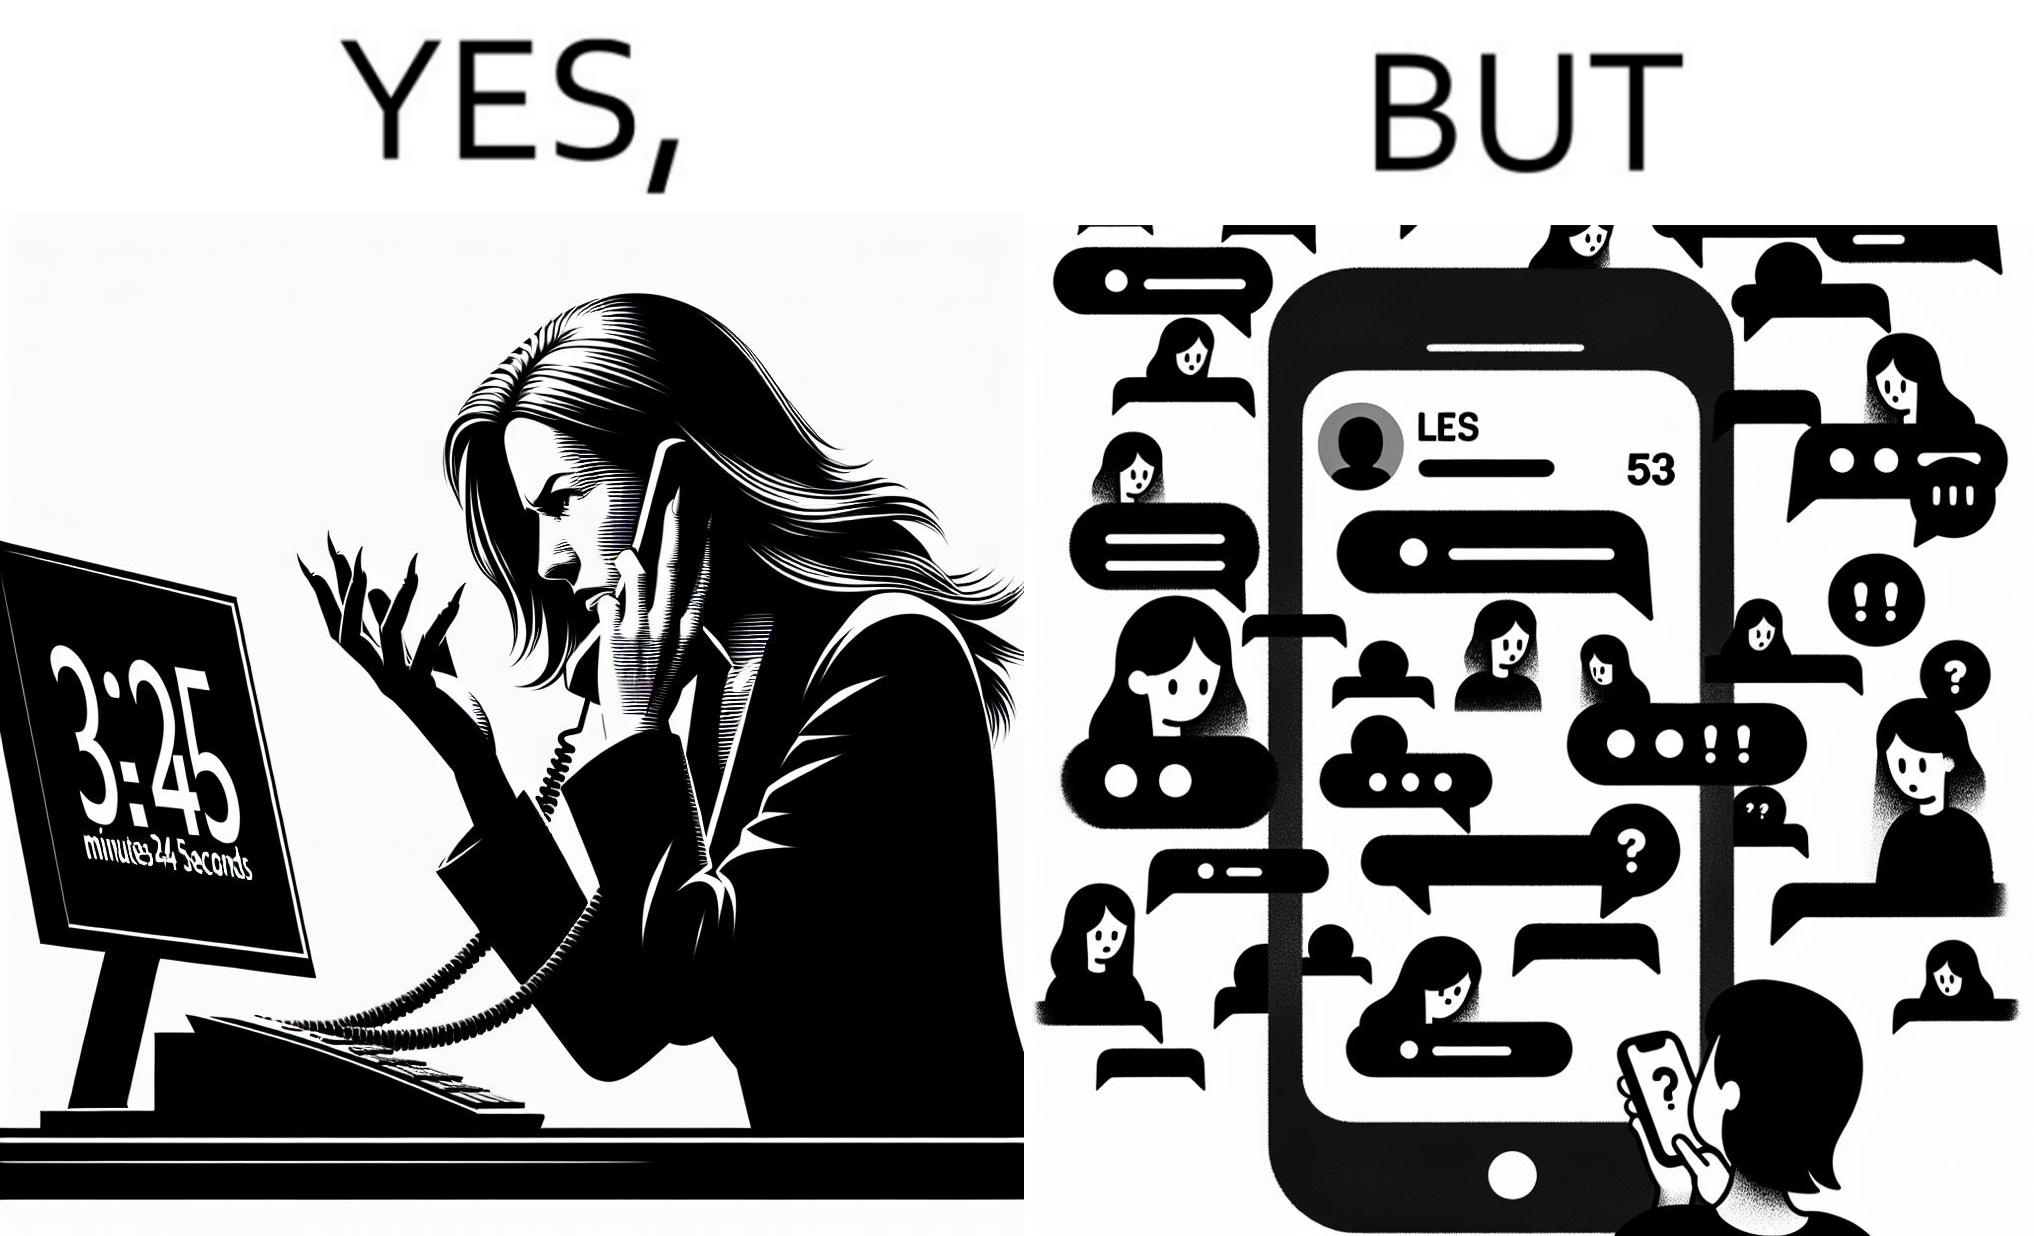What does this image depict? The image is ironical because while the woman is annoyed by the unresponsiveness of the call center, she herself is being unresponsive to many people in the chat. 